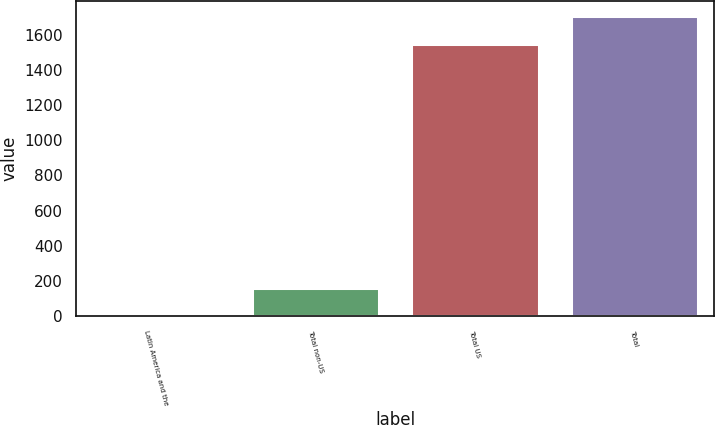Convert chart to OTSL. <chart><loc_0><loc_0><loc_500><loc_500><bar_chart><fcel>Latin America and the<fcel>Total non-US<fcel>Total US<fcel>Total<nl><fcel>6<fcel>163.1<fcel>1548<fcel>1705.1<nl></chart> 